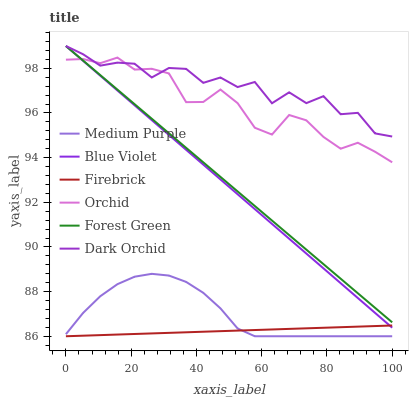Does Medium Purple have the minimum area under the curve?
Answer yes or no. No. Does Medium Purple have the maximum area under the curve?
Answer yes or no. No. Is Medium Purple the smoothest?
Answer yes or no. No. Is Medium Purple the roughest?
Answer yes or no. No. Does Dark Orchid have the lowest value?
Answer yes or no. No. Does Medium Purple have the highest value?
Answer yes or no. No. Is Firebrick less than Forest Green?
Answer yes or no. Yes. Is Dark Orchid greater than Medium Purple?
Answer yes or no. Yes. Does Firebrick intersect Forest Green?
Answer yes or no. No. 